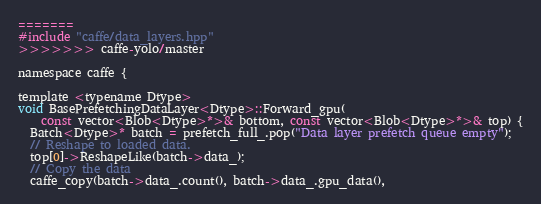Convert code to text. <code><loc_0><loc_0><loc_500><loc_500><_Cuda_>=======
#include "caffe/data_layers.hpp"
>>>>>>> caffe-yolo/master

namespace caffe {

template <typename Dtype>
void BasePrefetchingDataLayer<Dtype>::Forward_gpu(
    const vector<Blob<Dtype>*>& bottom, const vector<Blob<Dtype>*>& top) {
  Batch<Dtype>* batch = prefetch_full_.pop("Data layer prefetch queue empty");
  // Reshape to loaded data.
  top[0]->ReshapeLike(batch->data_);
  // Copy the data
  caffe_copy(batch->data_.count(), batch->data_.gpu_data(),</code> 